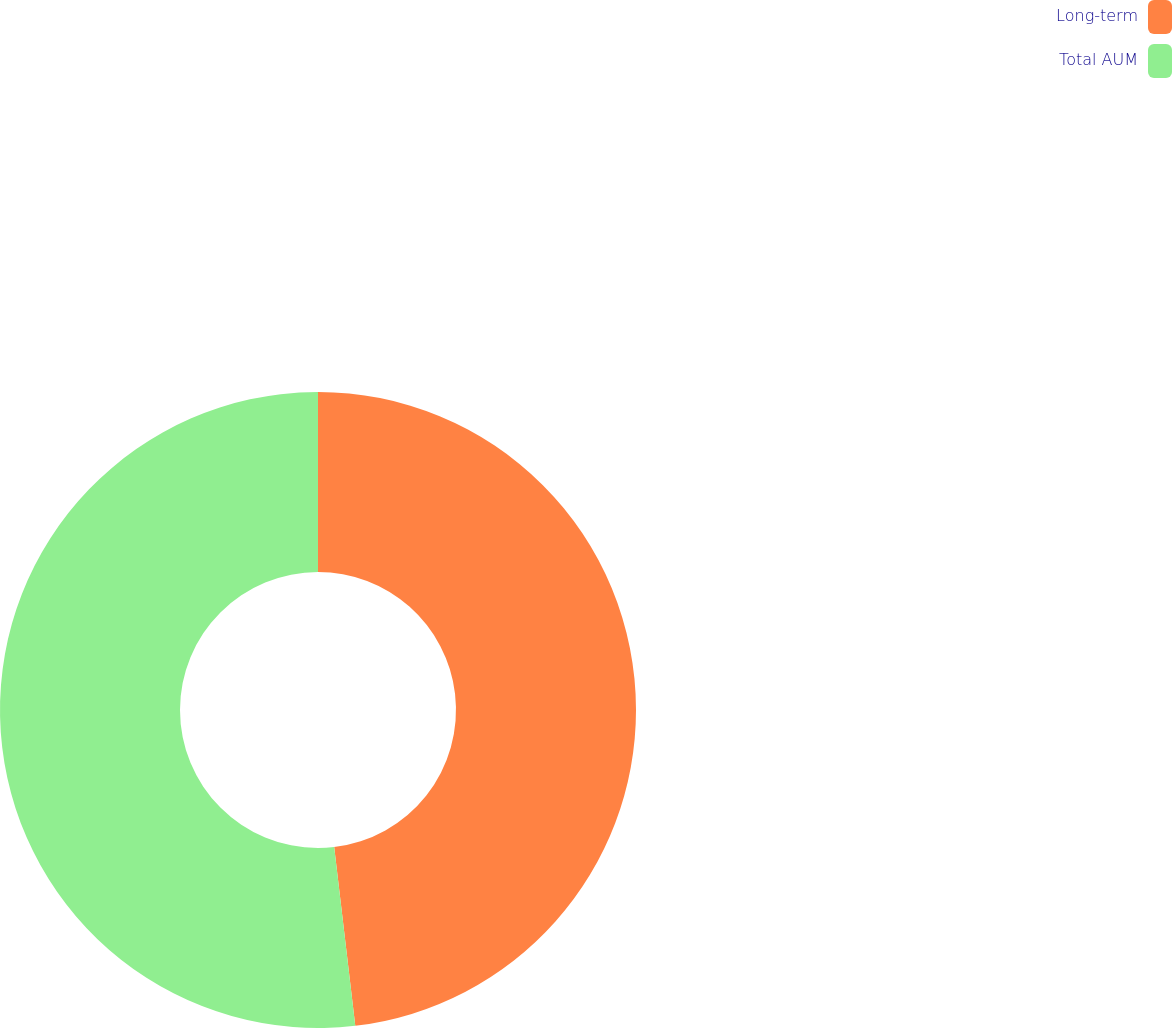Convert chart to OTSL. <chart><loc_0><loc_0><loc_500><loc_500><pie_chart><fcel>Long-term<fcel>Total AUM<nl><fcel>48.13%<fcel>51.87%<nl></chart> 